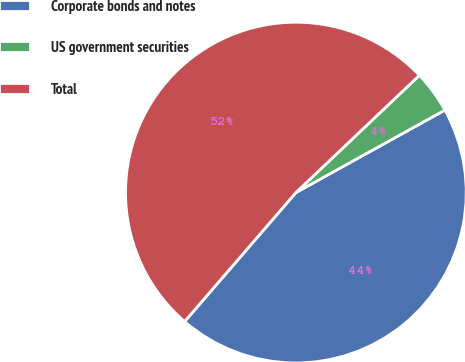Convert chart. <chart><loc_0><loc_0><loc_500><loc_500><pie_chart><fcel>Corporate bonds and notes<fcel>US government securities<fcel>Total<nl><fcel>44.38%<fcel>4.04%<fcel>51.58%<nl></chart> 